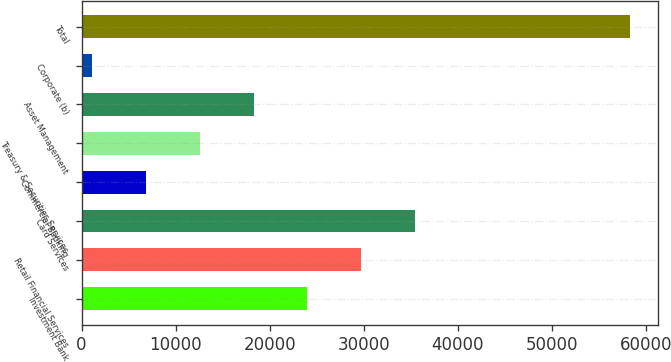Convert chart to OTSL. <chart><loc_0><loc_0><loc_500><loc_500><bar_chart><fcel>Investment Bank<fcel>Retail Financial Services<fcel>Card Services<fcel>Commercial Banking<fcel>Treasury & Securities Services<fcel>Asset Management<fcel>Corporate (b)<fcel>Total<nl><fcel>24027.2<fcel>29750<fcel>35472.8<fcel>6858.8<fcel>12581.6<fcel>18304.4<fcel>1136<fcel>58364<nl></chart> 